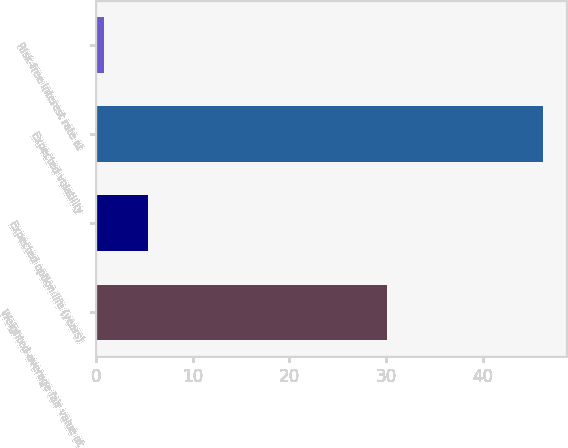Convert chart. <chart><loc_0><loc_0><loc_500><loc_500><bar_chart><fcel>Weighted-average fair value at<fcel>Expected option life (years)<fcel>Expected volatility<fcel>Risk-free interest rate at<nl><fcel>30.15<fcel>5.35<fcel>46.3<fcel>0.8<nl></chart> 